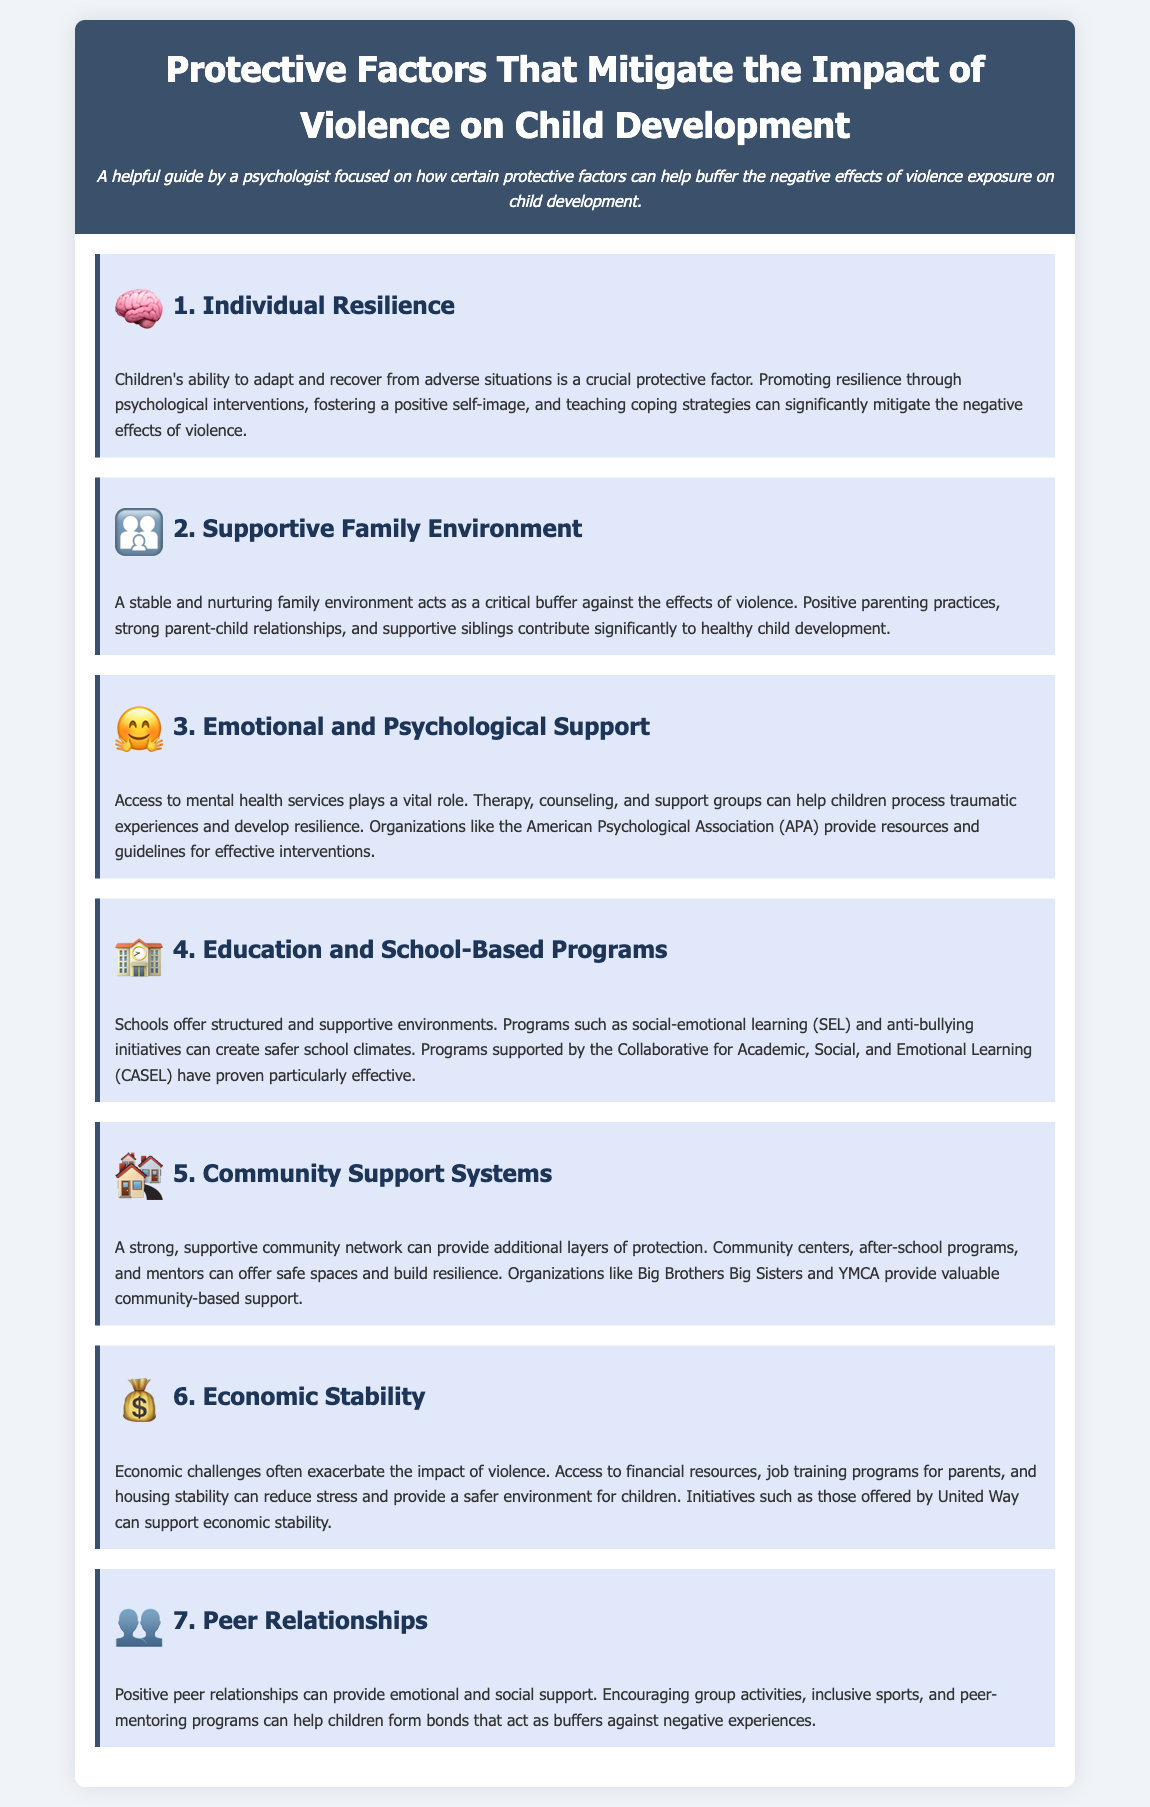What is the first protective factor listed? The first protective factor mentioned in the document is "Individual Resilience."
Answer: Individual Resilience What icon represents the supportive family environment? The icon associated with the supportive family environment is a family emoji (👪).
Answer: 👪 How many protective factors are outlined in the document? There are a total of seven protective factors outlined in the document.
Answer: 7 Which organization is mentioned in relation to emotional and psychological support? The American Psychological Association (APA) is highlighted for providing resources related to emotional support.
Answer: American Psychological Association What type of programs does CASEL support? CASEL supports programs such as social-emotional learning (SEL) and anti-bullying initiatives.
Answer: social-emotional learning What is a key benefit of positive peer relationships mentioned? Positive peer relationships provide emotional and social support for children.
Answer: emotional and social support Which protective factor includes access to financial resources? The protective factor that includes access to financial resources is "Economic Stability."
Answer: Economic Stability What is the second protective factor listed? The second protective factor mentioned is "Supportive Family Environment."
Answer: Supportive Family Environment 